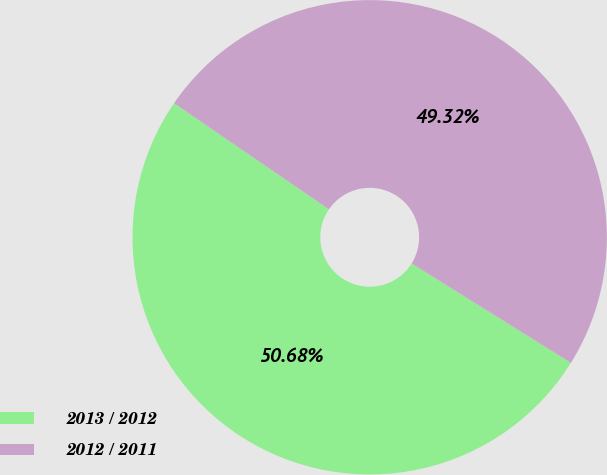Convert chart to OTSL. <chart><loc_0><loc_0><loc_500><loc_500><pie_chart><fcel>2013 / 2012<fcel>2012 / 2011<nl><fcel>50.68%<fcel>49.32%<nl></chart> 